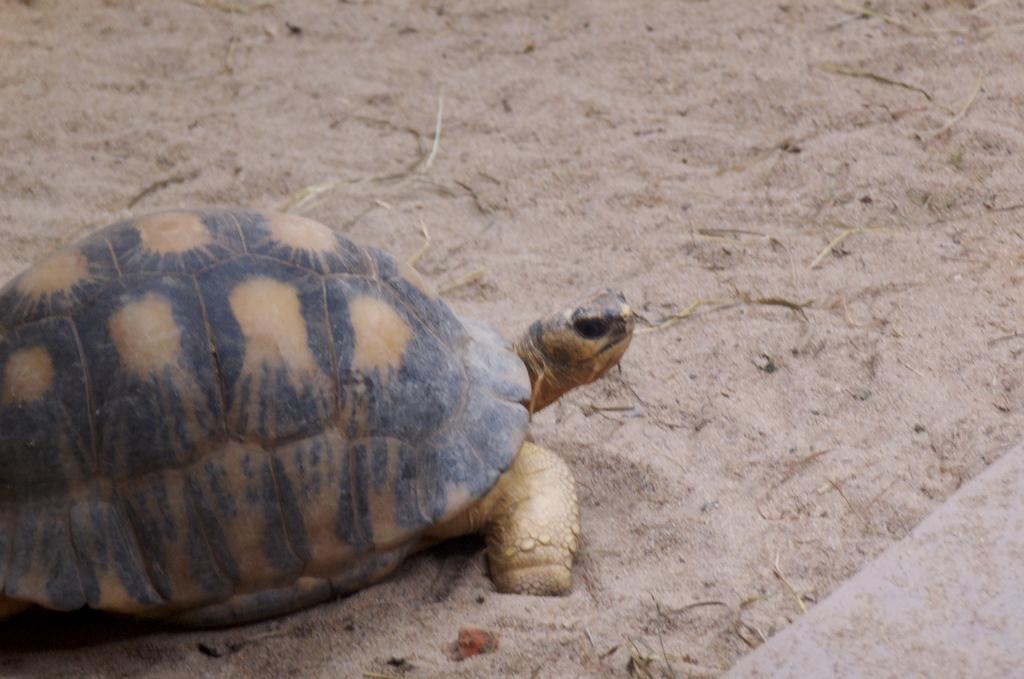Where was the image most likely taken? The image was likely clicked outside. What animal can be seen in the image? There is a tortoise in the image. What is the tortoise doing in the image? The tortoise is walking on the ground. What type of terrain is visible in the background of the image? There is sand visible in the background of the image. What type of knot can be seen in the image? There is no knot present in the image. Can you describe the fog in the image? There is no fog visible in the image. 